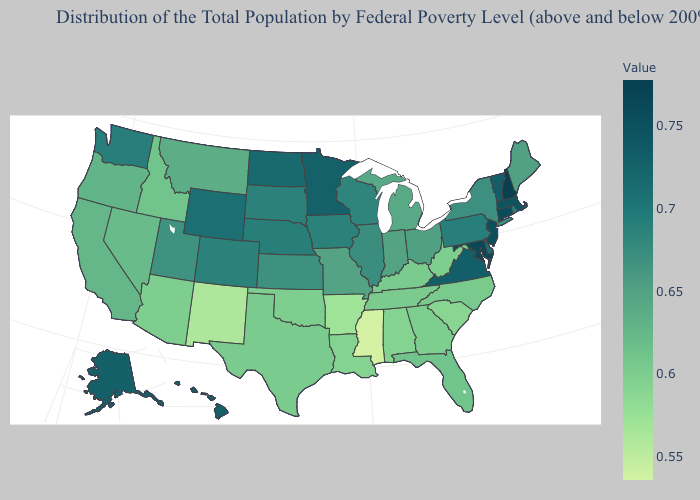Does New Hampshire have the highest value in the Northeast?
Write a very short answer. Yes. Among the states that border Oregon , does Nevada have the lowest value?
Concise answer only. No. Which states have the lowest value in the USA?
Quick response, please. Mississippi. Among the states that border Florida , which have the lowest value?
Be succinct. Alabama. Among the states that border Montana , does North Dakota have the lowest value?
Keep it brief. No. Does Virginia have the highest value in the South?
Concise answer only. No. Does Arkansas have a lower value than Maryland?
Concise answer only. Yes. Which states have the lowest value in the Northeast?
Give a very brief answer. Maine. 